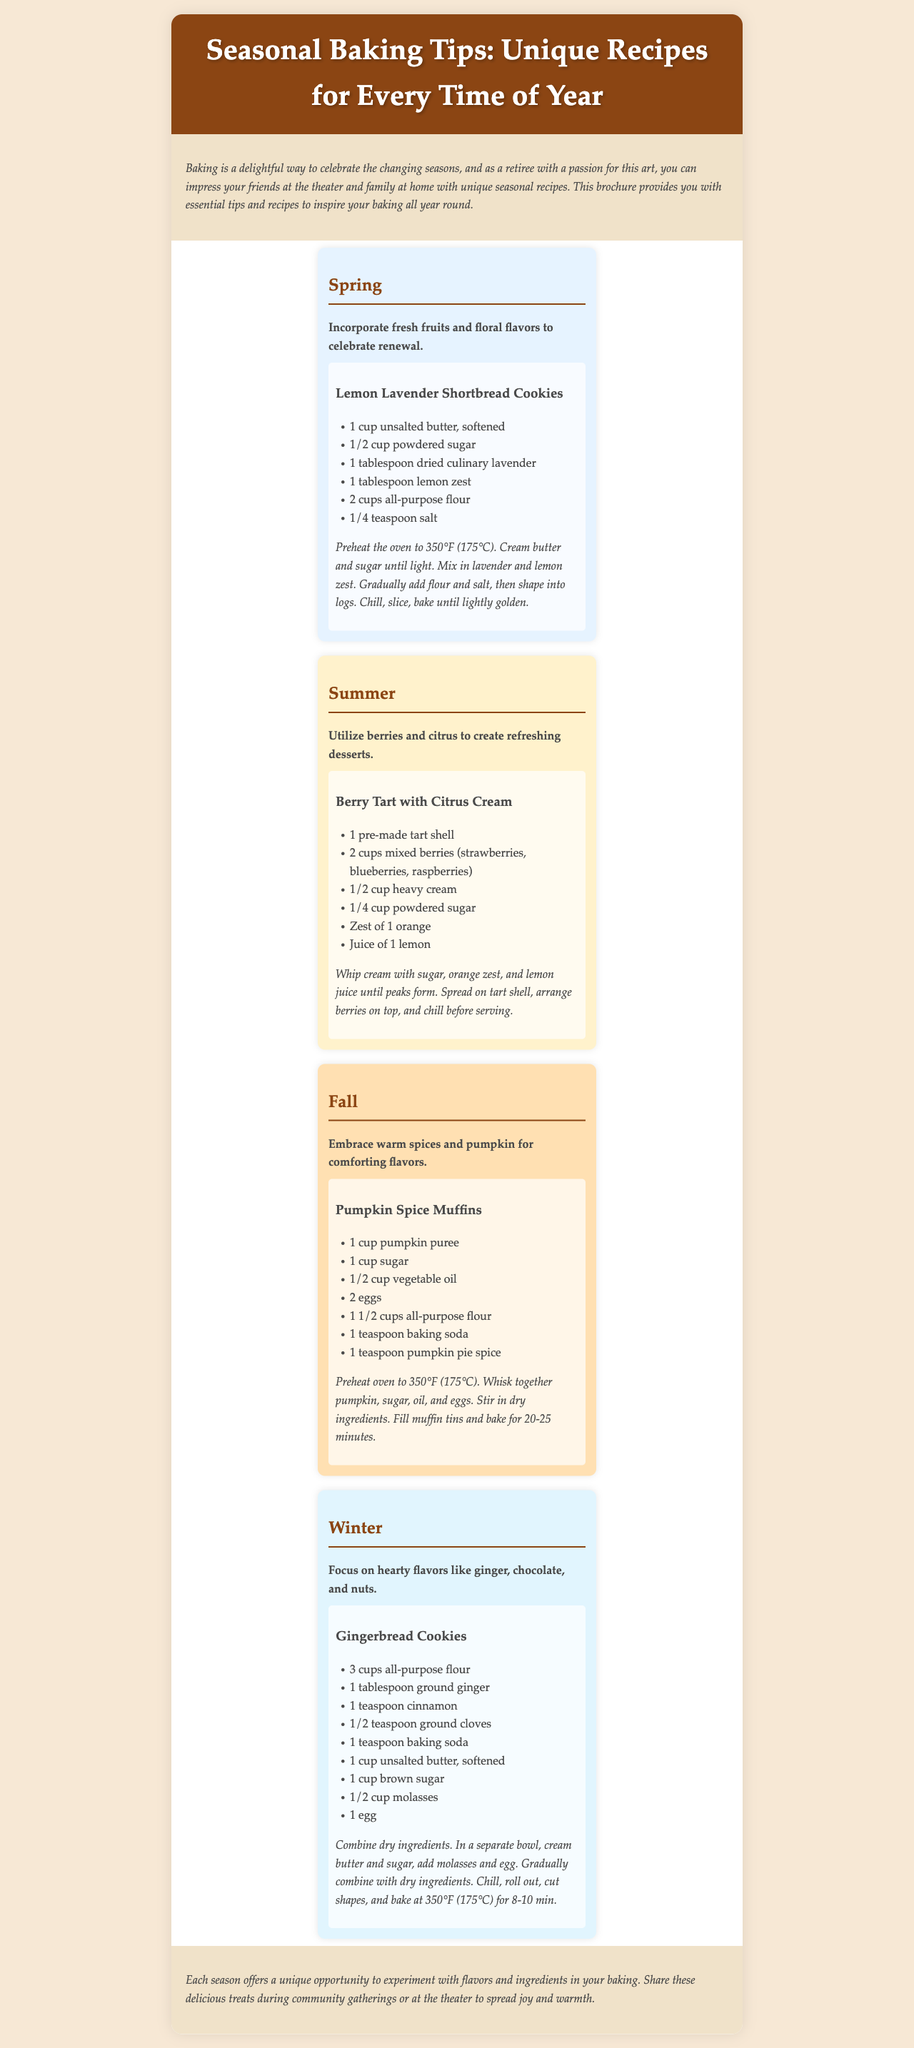What is the title of the brochure? The title of the brochure is displayed prominently at the top.
Answer: Seasonal Baking Tips: Unique Recipes for Every Time of Year How many recipes are provided in the brochure? There is one recipe for each of the four seasons, totaling four recipes.
Answer: 4 What is the main ingredient in Lemon Lavender Shortbread Cookies? The recipe lists unsalted butter as the first main ingredient.
Answer: Unsalted butter Which season is associated with warm spices and pumpkin? The content specifically mentions this seasonal baking characteristic under Fall.
Answer: Fall What temperature should the oven be preheated to for the Gingerbread Cookies? The recipe states the preheating temperature for baking Gingerbread Cookies.
Answer: 350°F (175°C) What type of dessert is suggested for summer? The brochure provides a specific dessert example for summer baking.
Answer: Berry Tart with Citrus Cream In which section would you find baking tips for incorporating fresh fruits? The section specifically describes this theme as it pertains to seasonal baking.
Answer: Spring What is a suggested tip for winter baking? The brochure lists a specific focus on flavors for winter baking.
Answer: Hearty flavors like ginger, chocolate, and nuts 